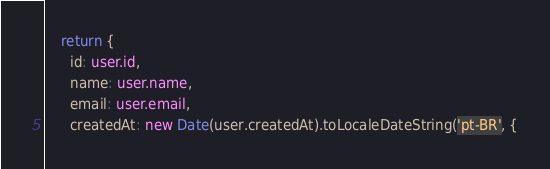<code> <loc_0><loc_0><loc_500><loc_500><_TypeScript_>    return {
      id: user.id,
      name: user.name,
      email: user.email,
      createdAt: new Date(user.createdAt).toLocaleDateString('pt-BR', {</code> 